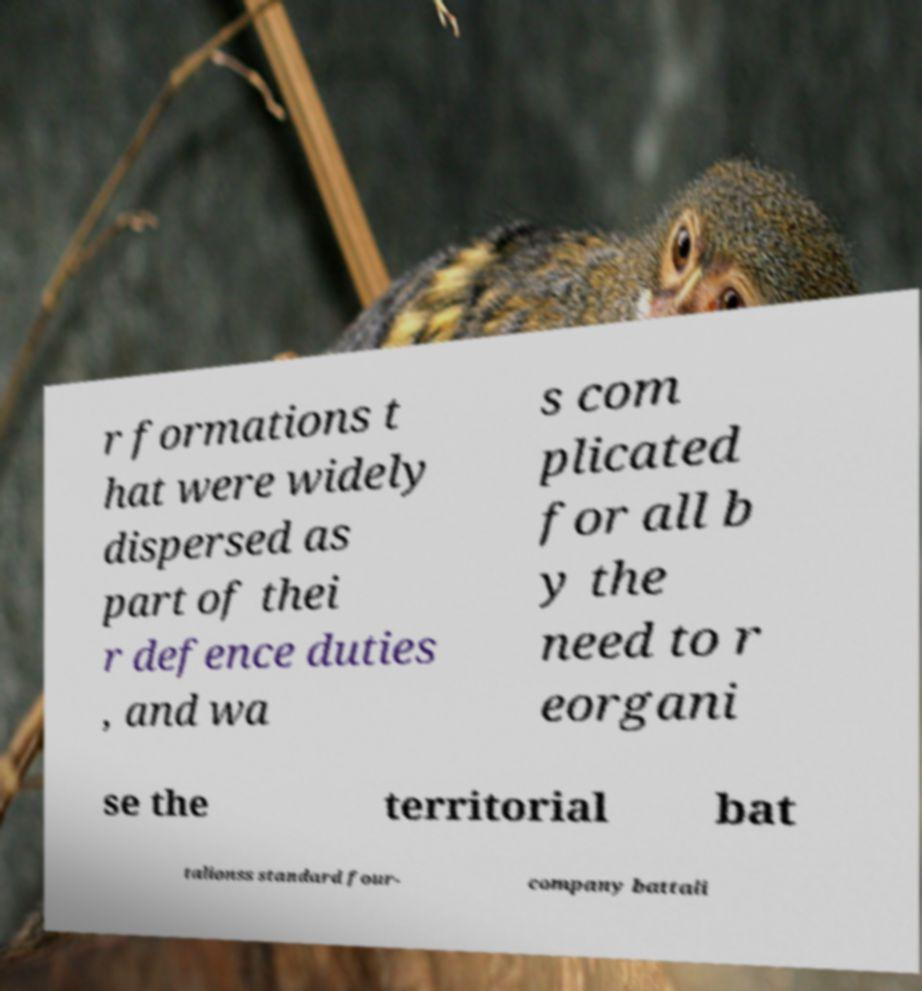Please identify and transcribe the text found in this image. r formations t hat were widely dispersed as part of thei r defence duties , and wa s com plicated for all b y the need to r eorgani se the territorial bat talionss standard four- company battali 